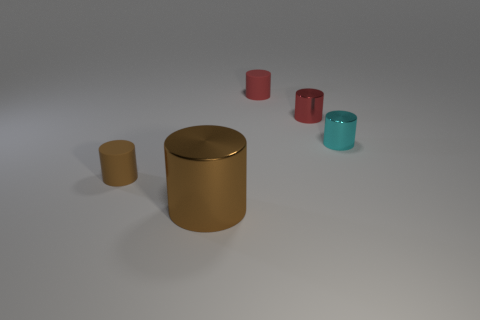Subtract all red cylinders. How many were subtracted if there are1red cylinders left? 1 Subtract all small metallic cylinders. How many cylinders are left? 3 Subtract all brown cylinders. How many cylinders are left? 3 Subtract all gray cylinders. Subtract all brown blocks. How many cylinders are left? 5 Add 1 small metal cylinders. How many objects exist? 6 Subtract 1 cylinders. How many cylinders are left? 4 Subtract all yellow spheres. How many cyan cylinders are left? 1 Subtract all big red matte cubes. Subtract all tiny brown matte cylinders. How many objects are left? 4 Add 5 tiny rubber things. How many tiny rubber things are left? 7 Add 2 tiny cyan metal cylinders. How many tiny cyan metal cylinders exist? 3 